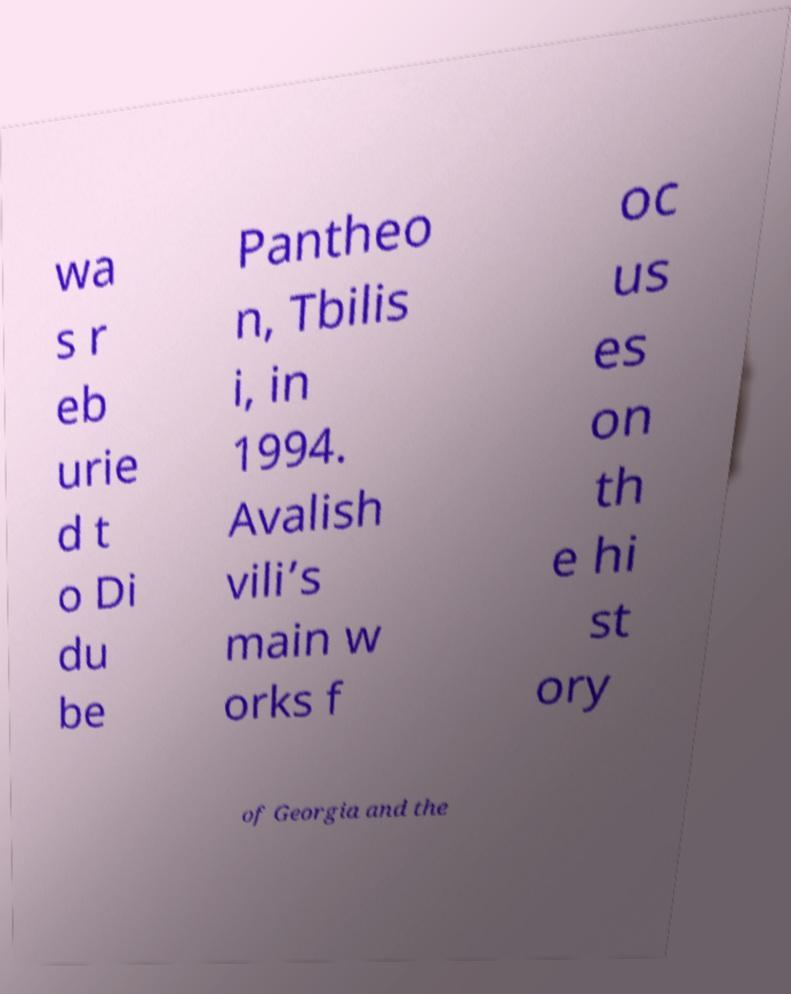I need the written content from this picture converted into text. Can you do that? wa s r eb urie d t o Di du be Pantheo n, Tbilis i, in 1994. Avalish vili’s main w orks f oc us es on th e hi st ory of Georgia and the 